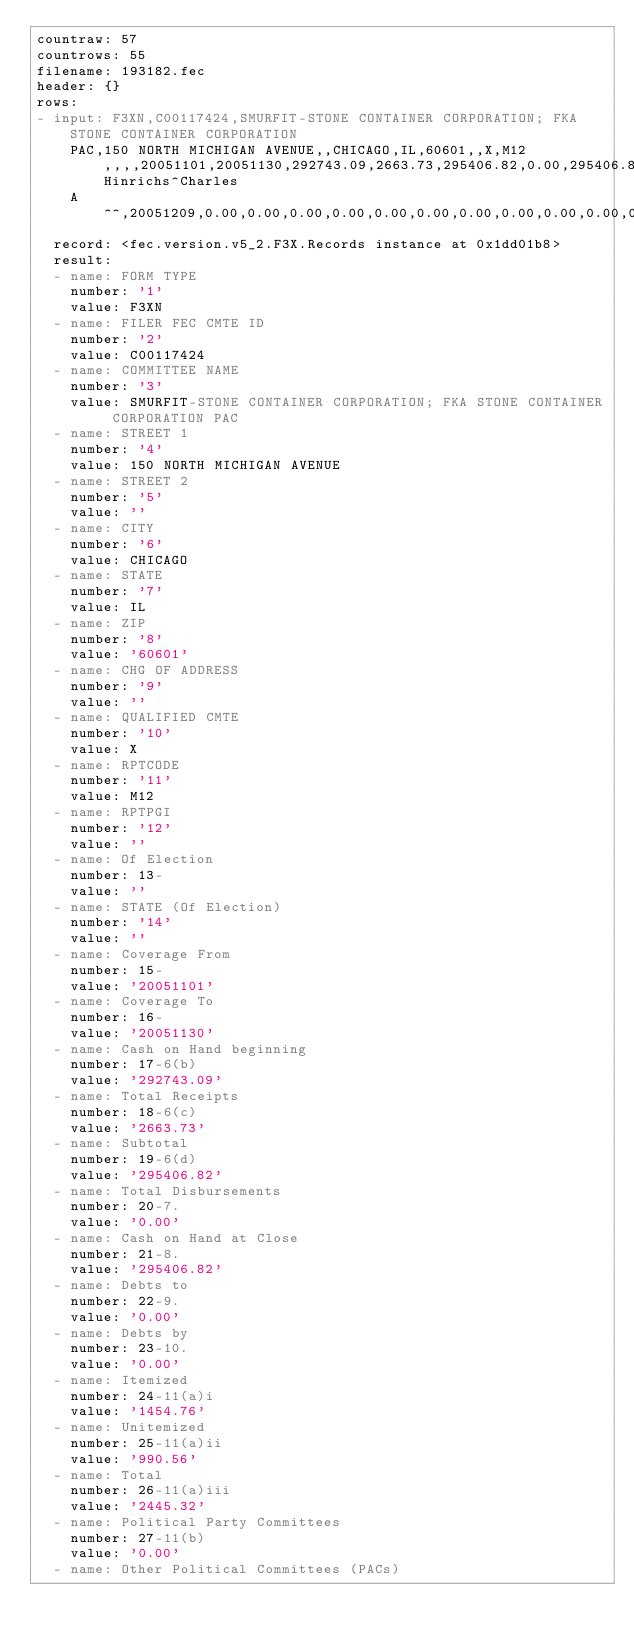<code> <loc_0><loc_0><loc_500><loc_500><_YAML_>countraw: 57
countrows: 55
filename: 193182.fec
header: {}
rows:
- input: F3XN,C00117424,SMURFIT-STONE CONTAINER CORPORATION; FKA STONE CONTAINER CORPORATION
    PAC,150 NORTH MICHIGAN AVENUE,,CHICAGO,IL,60601,,X,M12,,,,20051101,20051130,292743.09,2663.73,295406.82,0.00,295406.82,0.00,0.00,1454.76,990.56,2445.32,0.00,0.00,2445.32,0.00,0.00,0.00,0.00,0.00,218.41,0.00,2663.73,2663.73,0.00,0.00,0.00,0.00,0.00,0.00,0.00,0.00,0.00,0.00,0.00,0.00,0.00,0.00,0.00,0.00,0.00,2445.32,0.00,2445.32,0.00,0.00,0.00,279787.58,2005,29898.24,309685.82,14279.00,295406.82,9442.07,15764.72,25206.79,0.00,0.00,25206.79,0.00,0.00,0.00,0.00,0.00,4691.45,0.00,29898.24,29898.24,0.00,0.00,729.00,729.00,0.00,13550.00,0.00,0.00,0.00,0.00,0.00,0.00,0.00,0.00,0.00,14279.00,14279.00,25206.79,0.00,25206.79,729.00,0.00,729.00,Hinrichs^Charles
    A^^,20051209,0.00,0.00,0.00,0.00,0.00,0.00,0.00,0.00,0.00,0.00,0.00,0.00
  record: <fec.version.v5_2.F3X.Records instance at 0x1dd01b8>
  result:
  - name: FORM TYPE
    number: '1'
    value: F3XN
  - name: FILER FEC CMTE ID
    number: '2'
    value: C00117424
  - name: COMMITTEE NAME
    number: '3'
    value: SMURFIT-STONE CONTAINER CORPORATION; FKA STONE CONTAINER CORPORATION PAC
  - name: STREET 1
    number: '4'
    value: 150 NORTH MICHIGAN AVENUE
  - name: STREET 2
    number: '5'
    value: ''
  - name: CITY
    number: '6'
    value: CHICAGO
  - name: STATE
    number: '7'
    value: IL
  - name: ZIP
    number: '8'
    value: '60601'
  - name: CHG OF ADDRESS
    number: '9'
    value: ''
  - name: QUALIFIED CMTE
    number: '10'
    value: X
  - name: RPTCODE
    number: '11'
    value: M12
  - name: RPTPGI
    number: '12'
    value: ''
  - name: Of Election
    number: 13-
    value: ''
  - name: STATE (Of Election)
    number: '14'
    value: ''
  - name: Coverage From
    number: 15-
    value: '20051101'
  - name: Coverage To
    number: 16-
    value: '20051130'
  - name: Cash on Hand beginning
    number: 17-6(b)
    value: '292743.09'
  - name: Total Receipts
    number: 18-6(c)
    value: '2663.73'
  - name: Subtotal
    number: 19-6(d)
    value: '295406.82'
  - name: Total Disbursements
    number: 20-7.
    value: '0.00'
  - name: Cash on Hand at Close
    number: 21-8.
    value: '295406.82'
  - name: Debts to
    number: 22-9.
    value: '0.00'
  - name: Debts by
    number: 23-10.
    value: '0.00'
  - name: Itemized
    number: 24-11(a)i
    value: '1454.76'
  - name: Unitemized
    number: 25-11(a)ii
    value: '990.56'
  - name: Total
    number: 26-11(a)iii
    value: '2445.32'
  - name: Political Party Committees
    number: 27-11(b)
    value: '0.00'
  - name: Other Political Committees (PACs)</code> 